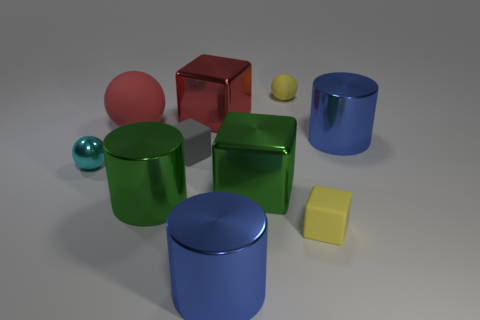Subtract all blue cylinders. How many were subtracted if there are1blue cylinders left? 1 Subtract 1 cubes. How many cubes are left? 3 Subtract all brown cubes. Subtract all purple cylinders. How many cubes are left? 4 Subtract all cylinders. How many objects are left? 7 Add 3 green cylinders. How many green cylinders are left? 4 Add 8 large red spheres. How many large red spheres exist? 9 Subtract 0 blue spheres. How many objects are left? 10 Subtract all green cylinders. Subtract all cylinders. How many objects are left? 6 